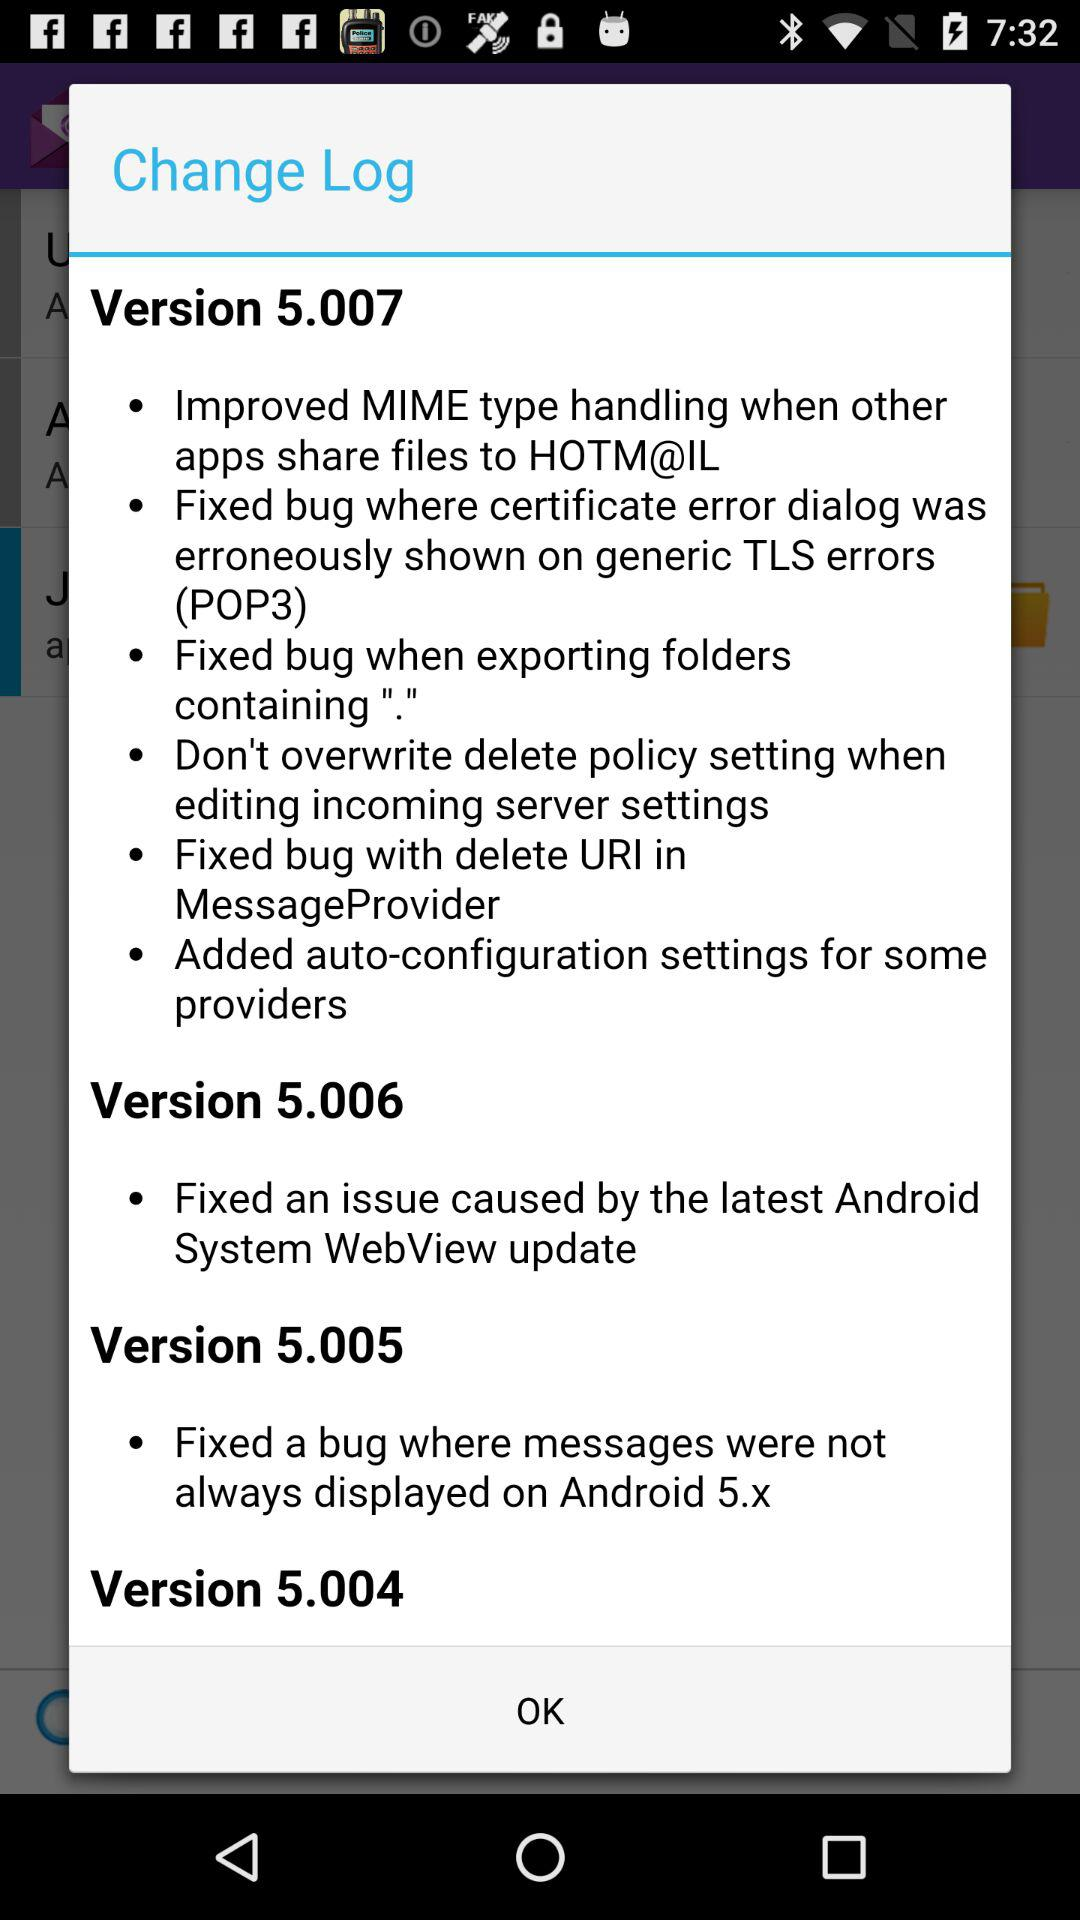What is the version that fixed an issue caused by the latest Android system WebView update? The version that fixed an issue caused by the latest Android system WebView update is 5.006. 